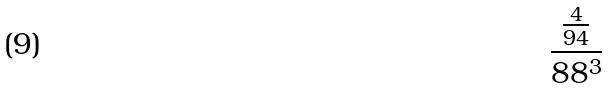Convert formula to latex. <formula><loc_0><loc_0><loc_500><loc_500>\frac { \frac { 4 } { 9 4 } } { 8 8 ^ { 3 } }</formula> 